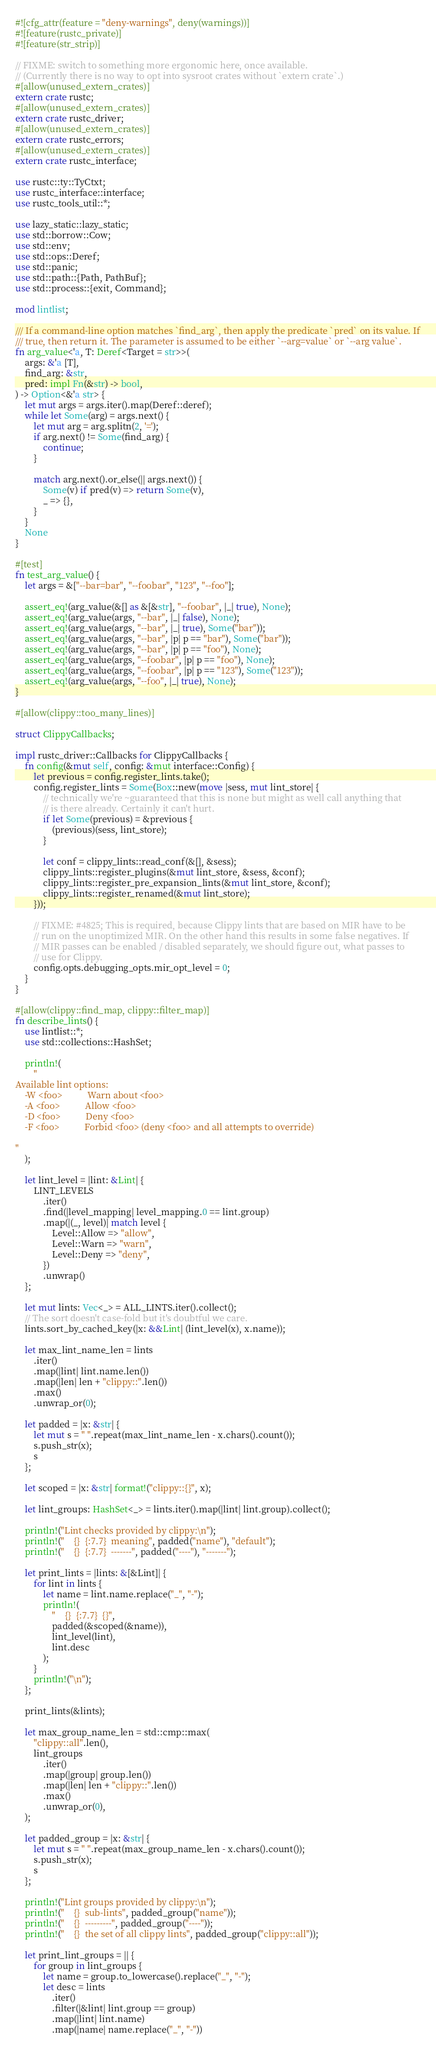<code> <loc_0><loc_0><loc_500><loc_500><_Rust_>#![cfg_attr(feature = "deny-warnings", deny(warnings))]
#![feature(rustc_private)]
#![feature(str_strip)]

// FIXME: switch to something more ergonomic here, once available.
// (Currently there is no way to opt into sysroot crates without `extern crate`.)
#[allow(unused_extern_crates)]
extern crate rustc;
#[allow(unused_extern_crates)]
extern crate rustc_driver;
#[allow(unused_extern_crates)]
extern crate rustc_errors;
#[allow(unused_extern_crates)]
extern crate rustc_interface;

use rustc::ty::TyCtxt;
use rustc_interface::interface;
use rustc_tools_util::*;

use lazy_static::lazy_static;
use std::borrow::Cow;
use std::env;
use std::ops::Deref;
use std::panic;
use std::path::{Path, PathBuf};
use std::process::{exit, Command};

mod lintlist;

/// If a command-line option matches `find_arg`, then apply the predicate `pred` on its value. If
/// true, then return it. The parameter is assumed to be either `--arg=value` or `--arg value`.
fn arg_value<'a, T: Deref<Target = str>>(
    args: &'a [T],
    find_arg: &str,
    pred: impl Fn(&str) -> bool,
) -> Option<&'a str> {
    let mut args = args.iter().map(Deref::deref);
    while let Some(arg) = args.next() {
        let mut arg = arg.splitn(2, '=');
        if arg.next() != Some(find_arg) {
            continue;
        }

        match arg.next().or_else(|| args.next()) {
            Some(v) if pred(v) => return Some(v),
            _ => {},
        }
    }
    None
}

#[test]
fn test_arg_value() {
    let args = &["--bar=bar", "--foobar", "123", "--foo"];

    assert_eq!(arg_value(&[] as &[&str], "--foobar", |_| true), None);
    assert_eq!(arg_value(args, "--bar", |_| false), None);
    assert_eq!(arg_value(args, "--bar", |_| true), Some("bar"));
    assert_eq!(arg_value(args, "--bar", |p| p == "bar"), Some("bar"));
    assert_eq!(arg_value(args, "--bar", |p| p == "foo"), None);
    assert_eq!(arg_value(args, "--foobar", |p| p == "foo"), None);
    assert_eq!(arg_value(args, "--foobar", |p| p == "123"), Some("123"));
    assert_eq!(arg_value(args, "--foo", |_| true), None);
}

#[allow(clippy::too_many_lines)]

struct ClippyCallbacks;

impl rustc_driver::Callbacks for ClippyCallbacks {
    fn config(&mut self, config: &mut interface::Config) {
        let previous = config.register_lints.take();
        config.register_lints = Some(Box::new(move |sess, mut lint_store| {
            // technically we're ~guaranteed that this is none but might as well call anything that
            // is there already. Certainly it can't hurt.
            if let Some(previous) = &previous {
                (previous)(sess, lint_store);
            }

            let conf = clippy_lints::read_conf(&[], &sess);
            clippy_lints::register_plugins(&mut lint_store, &sess, &conf);
            clippy_lints::register_pre_expansion_lints(&mut lint_store, &conf);
            clippy_lints::register_renamed(&mut lint_store);
        }));

        // FIXME: #4825; This is required, because Clippy lints that are based on MIR have to be
        // run on the unoptimized MIR. On the other hand this results in some false negatives. If
        // MIR passes can be enabled / disabled separately, we should figure out, what passes to
        // use for Clippy.
        config.opts.debugging_opts.mir_opt_level = 0;
    }
}

#[allow(clippy::find_map, clippy::filter_map)]
fn describe_lints() {
    use lintlist::*;
    use std::collections::HashSet;

    println!(
        "
Available lint options:
    -W <foo>           Warn about <foo>
    -A <foo>           Allow <foo>
    -D <foo>           Deny <foo>
    -F <foo>           Forbid <foo> (deny <foo> and all attempts to override)

"
    );

    let lint_level = |lint: &Lint| {
        LINT_LEVELS
            .iter()
            .find(|level_mapping| level_mapping.0 == lint.group)
            .map(|(_, level)| match level {
                Level::Allow => "allow",
                Level::Warn => "warn",
                Level::Deny => "deny",
            })
            .unwrap()
    };

    let mut lints: Vec<_> = ALL_LINTS.iter().collect();
    // The sort doesn't case-fold but it's doubtful we care.
    lints.sort_by_cached_key(|x: &&Lint| (lint_level(x), x.name));

    let max_lint_name_len = lints
        .iter()
        .map(|lint| lint.name.len())
        .map(|len| len + "clippy::".len())
        .max()
        .unwrap_or(0);

    let padded = |x: &str| {
        let mut s = " ".repeat(max_lint_name_len - x.chars().count());
        s.push_str(x);
        s
    };

    let scoped = |x: &str| format!("clippy::{}", x);

    let lint_groups: HashSet<_> = lints.iter().map(|lint| lint.group).collect();

    println!("Lint checks provided by clippy:\n");
    println!("    {}  {:7.7}  meaning", padded("name"), "default");
    println!("    {}  {:7.7}  -------", padded("----"), "-------");

    let print_lints = |lints: &[&Lint]| {
        for lint in lints {
            let name = lint.name.replace("_", "-");
            println!(
                "    {}  {:7.7}  {}",
                padded(&scoped(&name)),
                lint_level(lint),
                lint.desc
            );
        }
        println!("\n");
    };

    print_lints(&lints);

    let max_group_name_len = std::cmp::max(
        "clippy::all".len(),
        lint_groups
            .iter()
            .map(|group| group.len())
            .map(|len| len + "clippy::".len())
            .max()
            .unwrap_or(0),
    );

    let padded_group = |x: &str| {
        let mut s = " ".repeat(max_group_name_len - x.chars().count());
        s.push_str(x);
        s
    };

    println!("Lint groups provided by clippy:\n");
    println!("    {}  sub-lints", padded_group("name"));
    println!("    {}  ---------", padded_group("----"));
    println!("    {}  the set of all clippy lints", padded_group("clippy::all"));

    let print_lint_groups = || {
        for group in lint_groups {
            let name = group.to_lowercase().replace("_", "-");
            let desc = lints
                .iter()
                .filter(|&lint| lint.group == group)
                .map(|lint| lint.name)
                .map(|name| name.replace("_", "-"))</code> 